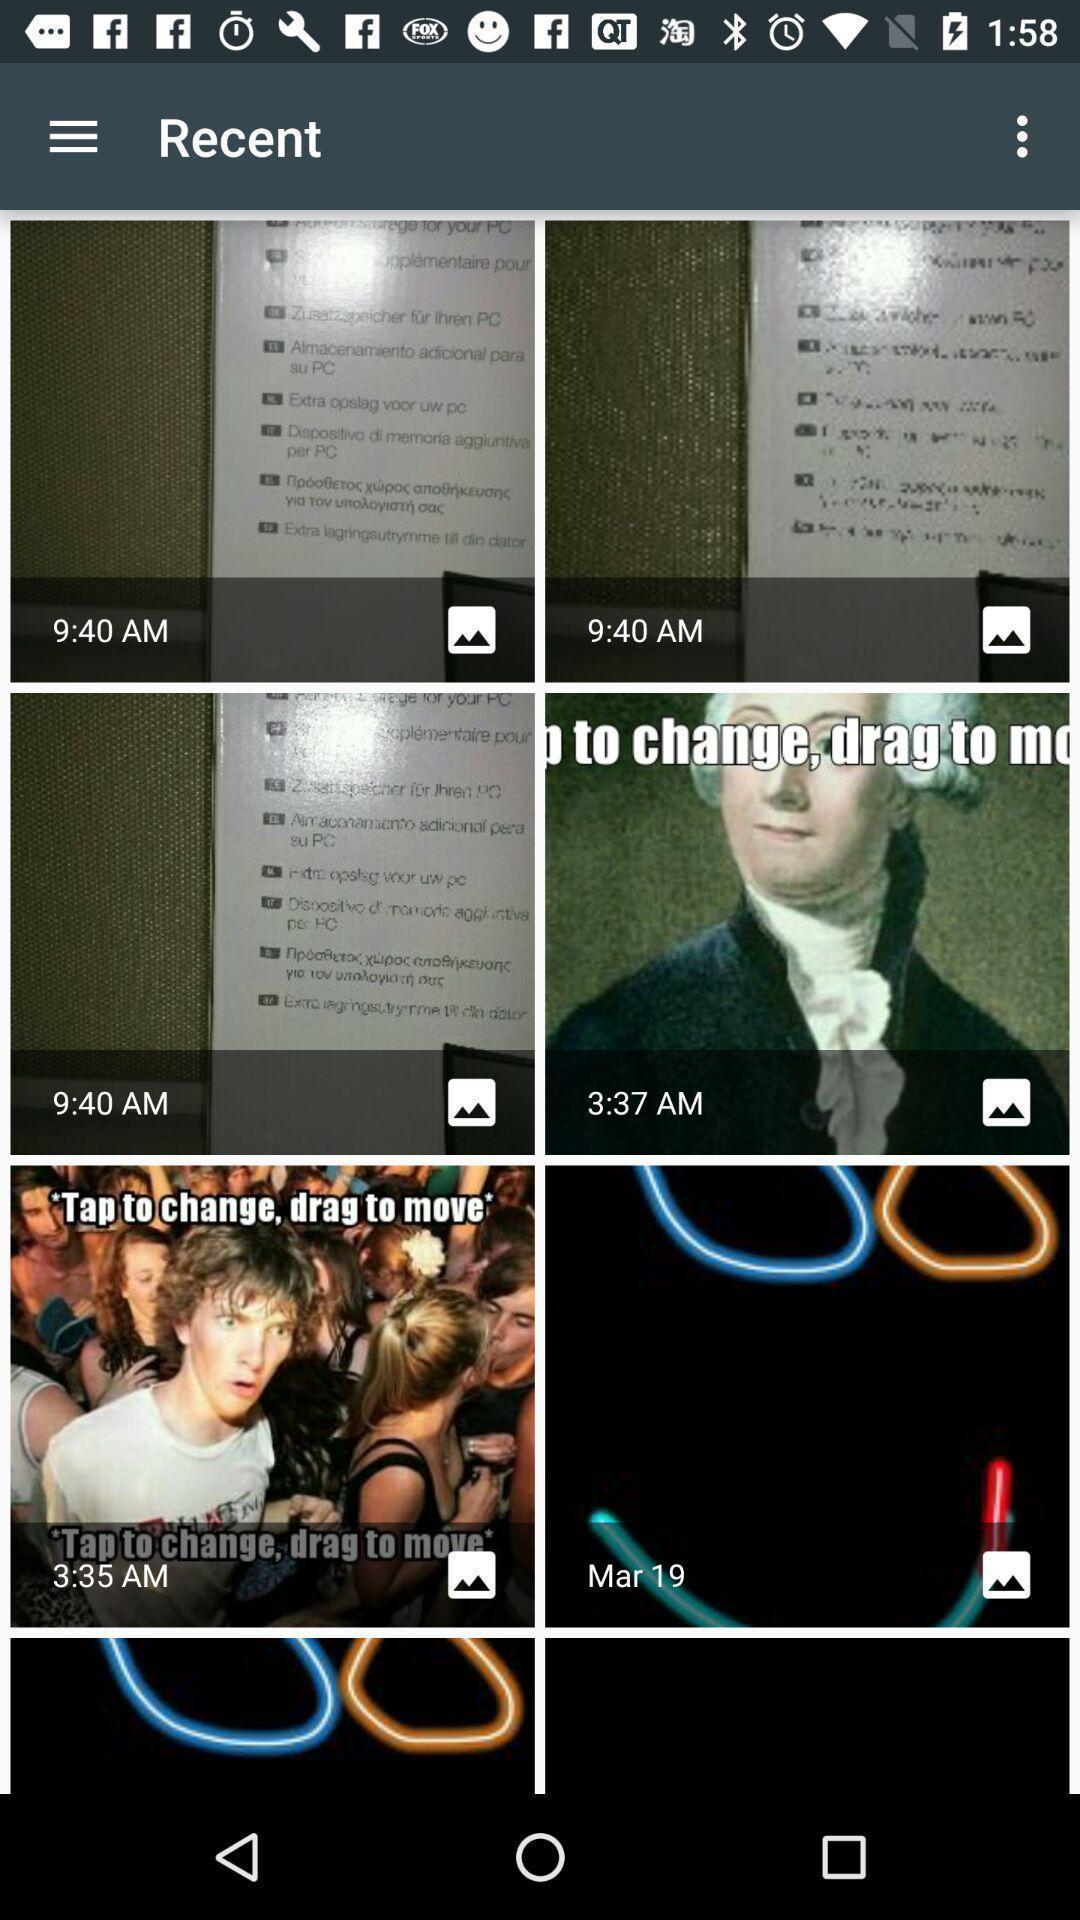Summarize the information in this screenshot. Screen displaying multiple images with time in a gallery. 